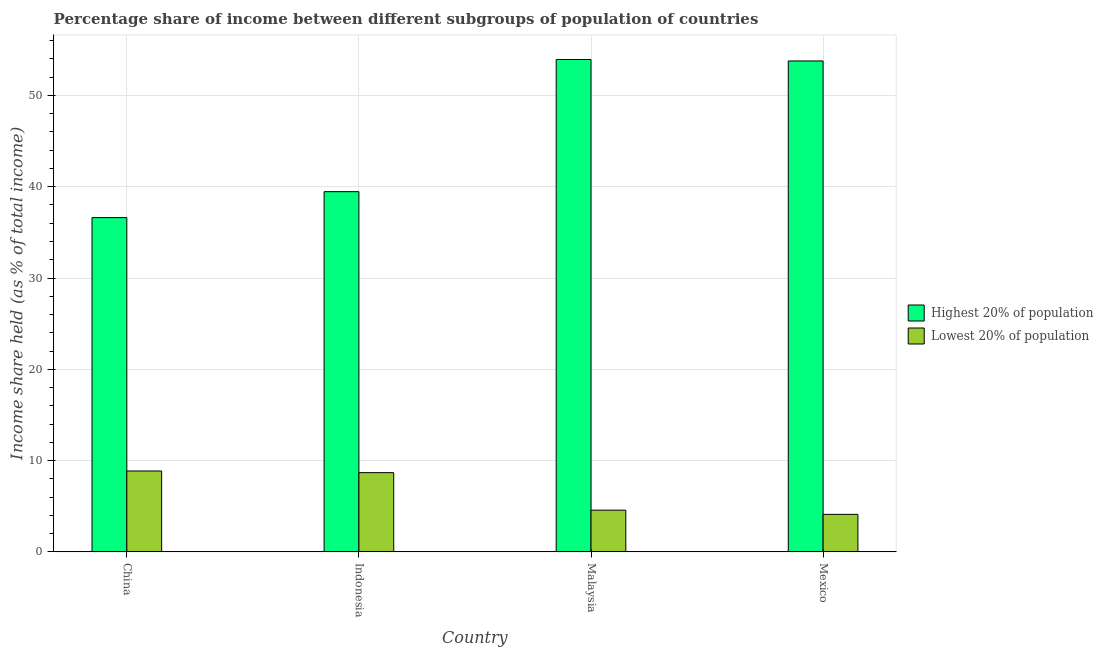Are the number of bars on each tick of the X-axis equal?
Your response must be concise. Yes. How many bars are there on the 2nd tick from the left?
Offer a terse response. 2. How many bars are there on the 1st tick from the right?
Offer a very short reply. 2. What is the label of the 2nd group of bars from the left?
Your answer should be compact. Indonesia. What is the income share held by lowest 20% of the population in Mexico?
Keep it short and to the point. 4.11. Across all countries, what is the maximum income share held by lowest 20% of the population?
Your answer should be very brief. 8.86. Across all countries, what is the minimum income share held by lowest 20% of the population?
Ensure brevity in your answer.  4.11. In which country was the income share held by highest 20% of the population maximum?
Offer a very short reply. Malaysia. What is the total income share held by lowest 20% of the population in the graph?
Give a very brief answer. 26.22. What is the difference between the income share held by lowest 20% of the population in China and that in Malaysia?
Ensure brevity in your answer.  4.29. What is the difference between the income share held by highest 20% of the population in China and the income share held by lowest 20% of the population in Indonesia?
Your answer should be compact. 27.94. What is the average income share held by lowest 20% of the population per country?
Make the answer very short. 6.55. What is the difference between the income share held by lowest 20% of the population and income share held by highest 20% of the population in Malaysia?
Give a very brief answer. -49.37. In how many countries, is the income share held by lowest 20% of the population greater than 46 %?
Provide a succinct answer. 0. What is the ratio of the income share held by highest 20% of the population in China to that in Mexico?
Your answer should be very brief. 0.68. Is the difference between the income share held by lowest 20% of the population in China and Mexico greater than the difference between the income share held by highest 20% of the population in China and Mexico?
Give a very brief answer. Yes. What is the difference between the highest and the second highest income share held by highest 20% of the population?
Your answer should be very brief. 0.16. What is the difference between the highest and the lowest income share held by highest 20% of the population?
Offer a terse response. 17.32. In how many countries, is the income share held by highest 20% of the population greater than the average income share held by highest 20% of the population taken over all countries?
Offer a terse response. 2. Is the sum of the income share held by lowest 20% of the population in Indonesia and Mexico greater than the maximum income share held by highest 20% of the population across all countries?
Offer a terse response. No. What does the 1st bar from the left in Mexico represents?
Offer a terse response. Highest 20% of population. What does the 2nd bar from the right in Indonesia represents?
Ensure brevity in your answer.  Highest 20% of population. How many bars are there?
Your answer should be compact. 8. How many countries are there in the graph?
Give a very brief answer. 4. What is the difference between two consecutive major ticks on the Y-axis?
Keep it short and to the point. 10. Are the values on the major ticks of Y-axis written in scientific E-notation?
Keep it short and to the point. No. Does the graph contain any zero values?
Keep it short and to the point. No. Where does the legend appear in the graph?
Keep it short and to the point. Center right. How are the legend labels stacked?
Your response must be concise. Vertical. What is the title of the graph?
Offer a very short reply. Percentage share of income between different subgroups of population of countries. Does "DAC donors" appear as one of the legend labels in the graph?
Your answer should be very brief. No. What is the label or title of the Y-axis?
Your answer should be compact. Income share held (as % of total income). What is the Income share held (as % of total income) in Highest 20% of population in China?
Your response must be concise. 36.62. What is the Income share held (as % of total income) of Lowest 20% of population in China?
Provide a short and direct response. 8.86. What is the Income share held (as % of total income) in Highest 20% of population in Indonesia?
Make the answer very short. 39.46. What is the Income share held (as % of total income) in Lowest 20% of population in Indonesia?
Your response must be concise. 8.68. What is the Income share held (as % of total income) of Highest 20% of population in Malaysia?
Give a very brief answer. 53.94. What is the Income share held (as % of total income) in Lowest 20% of population in Malaysia?
Make the answer very short. 4.57. What is the Income share held (as % of total income) of Highest 20% of population in Mexico?
Offer a terse response. 53.78. What is the Income share held (as % of total income) in Lowest 20% of population in Mexico?
Ensure brevity in your answer.  4.11. Across all countries, what is the maximum Income share held (as % of total income) in Highest 20% of population?
Make the answer very short. 53.94. Across all countries, what is the maximum Income share held (as % of total income) of Lowest 20% of population?
Make the answer very short. 8.86. Across all countries, what is the minimum Income share held (as % of total income) of Highest 20% of population?
Keep it short and to the point. 36.62. Across all countries, what is the minimum Income share held (as % of total income) in Lowest 20% of population?
Your response must be concise. 4.11. What is the total Income share held (as % of total income) of Highest 20% of population in the graph?
Make the answer very short. 183.8. What is the total Income share held (as % of total income) of Lowest 20% of population in the graph?
Make the answer very short. 26.22. What is the difference between the Income share held (as % of total income) in Highest 20% of population in China and that in Indonesia?
Give a very brief answer. -2.84. What is the difference between the Income share held (as % of total income) of Lowest 20% of population in China and that in Indonesia?
Your response must be concise. 0.18. What is the difference between the Income share held (as % of total income) in Highest 20% of population in China and that in Malaysia?
Ensure brevity in your answer.  -17.32. What is the difference between the Income share held (as % of total income) of Lowest 20% of population in China and that in Malaysia?
Offer a terse response. 4.29. What is the difference between the Income share held (as % of total income) in Highest 20% of population in China and that in Mexico?
Make the answer very short. -17.16. What is the difference between the Income share held (as % of total income) in Lowest 20% of population in China and that in Mexico?
Give a very brief answer. 4.75. What is the difference between the Income share held (as % of total income) of Highest 20% of population in Indonesia and that in Malaysia?
Your response must be concise. -14.48. What is the difference between the Income share held (as % of total income) in Lowest 20% of population in Indonesia and that in Malaysia?
Provide a short and direct response. 4.11. What is the difference between the Income share held (as % of total income) of Highest 20% of population in Indonesia and that in Mexico?
Keep it short and to the point. -14.32. What is the difference between the Income share held (as % of total income) of Lowest 20% of population in Indonesia and that in Mexico?
Your answer should be very brief. 4.57. What is the difference between the Income share held (as % of total income) of Highest 20% of population in Malaysia and that in Mexico?
Keep it short and to the point. 0.16. What is the difference between the Income share held (as % of total income) of Lowest 20% of population in Malaysia and that in Mexico?
Your answer should be compact. 0.46. What is the difference between the Income share held (as % of total income) of Highest 20% of population in China and the Income share held (as % of total income) of Lowest 20% of population in Indonesia?
Offer a terse response. 27.94. What is the difference between the Income share held (as % of total income) of Highest 20% of population in China and the Income share held (as % of total income) of Lowest 20% of population in Malaysia?
Give a very brief answer. 32.05. What is the difference between the Income share held (as % of total income) in Highest 20% of population in China and the Income share held (as % of total income) in Lowest 20% of population in Mexico?
Provide a short and direct response. 32.51. What is the difference between the Income share held (as % of total income) in Highest 20% of population in Indonesia and the Income share held (as % of total income) in Lowest 20% of population in Malaysia?
Provide a succinct answer. 34.89. What is the difference between the Income share held (as % of total income) in Highest 20% of population in Indonesia and the Income share held (as % of total income) in Lowest 20% of population in Mexico?
Your answer should be compact. 35.35. What is the difference between the Income share held (as % of total income) of Highest 20% of population in Malaysia and the Income share held (as % of total income) of Lowest 20% of population in Mexico?
Give a very brief answer. 49.83. What is the average Income share held (as % of total income) in Highest 20% of population per country?
Provide a succinct answer. 45.95. What is the average Income share held (as % of total income) of Lowest 20% of population per country?
Make the answer very short. 6.55. What is the difference between the Income share held (as % of total income) in Highest 20% of population and Income share held (as % of total income) in Lowest 20% of population in China?
Provide a succinct answer. 27.76. What is the difference between the Income share held (as % of total income) in Highest 20% of population and Income share held (as % of total income) in Lowest 20% of population in Indonesia?
Give a very brief answer. 30.78. What is the difference between the Income share held (as % of total income) of Highest 20% of population and Income share held (as % of total income) of Lowest 20% of population in Malaysia?
Your answer should be very brief. 49.37. What is the difference between the Income share held (as % of total income) in Highest 20% of population and Income share held (as % of total income) in Lowest 20% of population in Mexico?
Your answer should be very brief. 49.67. What is the ratio of the Income share held (as % of total income) in Highest 20% of population in China to that in Indonesia?
Ensure brevity in your answer.  0.93. What is the ratio of the Income share held (as % of total income) of Lowest 20% of population in China to that in Indonesia?
Provide a succinct answer. 1.02. What is the ratio of the Income share held (as % of total income) in Highest 20% of population in China to that in Malaysia?
Keep it short and to the point. 0.68. What is the ratio of the Income share held (as % of total income) in Lowest 20% of population in China to that in Malaysia?
Offer a very short reply. 1.94. What is the ratio of the Income share held (as % of total income) of Highest 20% of population in China to that in Mexico?
Provide a short and direct response. 0.68. What is the ratio of the Income share held (as % of total income) in Lowest 20% of population in China to that in Mexico?
Give a very brief answer. 2.16. What is the ratio of the Income share held (as % of total income) in Highest 20% of population in Indonesia to that in Malaysia?
Your response must be concise. 0.73. What is the ratio of the Income share held (as % of total income) of Lowest 20% of population in Indonesia to that in Malaysia?
Make the answer very short. 1.9. What is the ratio of the Income share held (as % of total income) of Highest 20% of population in Indonesia to that in Mexico?
Keep it short and to the point. 0.73. What is the ratio of the Income share held (as % of total income) in Lowest 20% of population in Indonesia to that in Mexico?
Provide a short and direct response. 2.11. What is the ratio of the Income share held (as % of total income) in Lowest 20% of population in Malaysia to that in Mexico?
Your response must be concise. 1.11. What is the difference between the highest and the second highest Income share held (as % of total income) of Highest 20% of population?
Give a very brief answer. 0.16. What is the difference between the highest and the second highest Income share held (as % of total income) of Lowest 20% of population?
Make the answer very short. 0.18. What is the difference between the highest and the lowest Income share held (as % of total income) in Highest 20% of population?
Your response must be concise. 17.32. What is the difference between the highest and the lowest Income share held (as % of total income) in Lowest 20% of population?
Give a very brief answer. 4.75. 